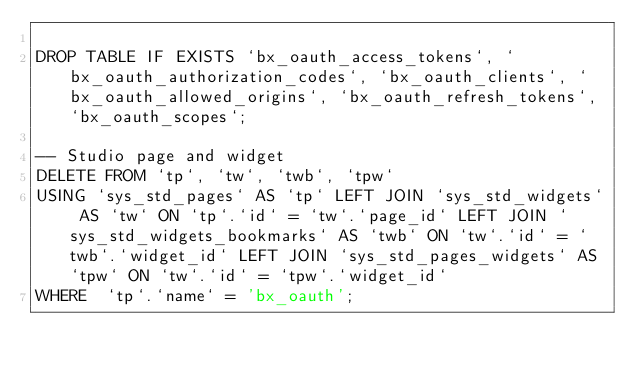Convert code to text. <code><loc_0><loc_0><loc_500><loc_500><_SQL_>
DROP TABLE IF EXISTS `bx_oauth_access_tokens`, `bx_oauth_authorization_codes`, `bx_oauth_clients`, `bx_oauth_allowed_origins`, `bx_oauth_refresh_tokens`, `bx_oauth_scopes`;

-- Studio page and widget
DELETE FROM `tp`, `tw`, `twb`, `tpw` 
USING `sys_std_pages` AS `tp` LEFT JOIN `sys_std_widgets` AS `tw` ON `tp`.`id` = `tw`.`page_id` LEFT JOIN `sys_std_widgets_bookmarks` AS `twb` ON `tw`.`id` = `twb`.`widget_id` LEFT JOIN `sys_std_pages_widgets` AS `tpw` ON `tw`.`id` = `tpw`.`widget_id`
WHERE  `tp`.`name` = 'bx_oauth';
</code> 